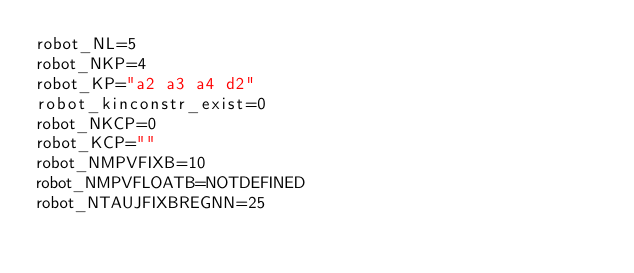<code> <loc_0><loc_0><loc_500><loc_500><_Bash_>robot_NL=5
robot_NKP=4
robot_KP="a2 a3 a4 d2"
robot_kinconstr_exist=0
robot_NKCP=0
robot_KCP=""
robot_NMPVFIXB=10
robot_NMPVFLOATB=NOTDEFINED
robot_NTAUJFIXBREGNN=25
</code> 